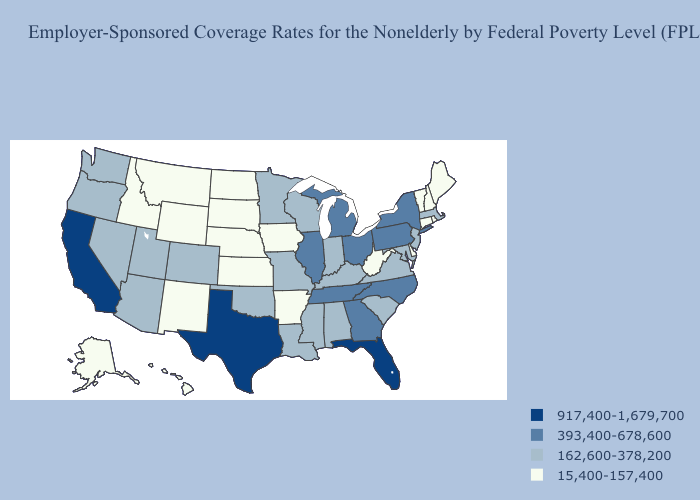Among the states that border Minnesota , which have the highest value?
Short answer required. Wisconsin. Among the states that border Utah , which have the lowest value?
Be succinct. Idaho, New Mexico, Wyoming. Among the states that border Wyoming , does Montana have the highest value?
Give a very brief answer. No. What is the highest value in states that border Michigan?
Answer briefly. 393,400-678,600. What is the value of Washington?
Write a very short answer. 162,600-378,200. Name the states that have a value in the range 917,400-1,679,700?
Answer briefly. California, Florida, Texas. Does Massachusetts have the highest value in the Northeast?
Write a very short answer. No. Name the states that have a value in the range 917,400-1,679,700?
Quick response, please. California, Florida, Texas. What is the value of Rhode Island?
Concise answer only. 15,400-157,400. Among the states that border Kansas , does Nebraska have the lowest value?
Be succinct. Yes. What is the value of Washington?
Short answer required. 162,600-378,200. What is the value of Wisconsin?
Short answer required. 162,600-378,200. What is the value of Tennessee?
Concise answer only. 393,400-678,600. Is the legend a continuous bar?
Short answer required. No. Among the states that border Vermont , which have the highest value?
Give a very brief answer. New York. 